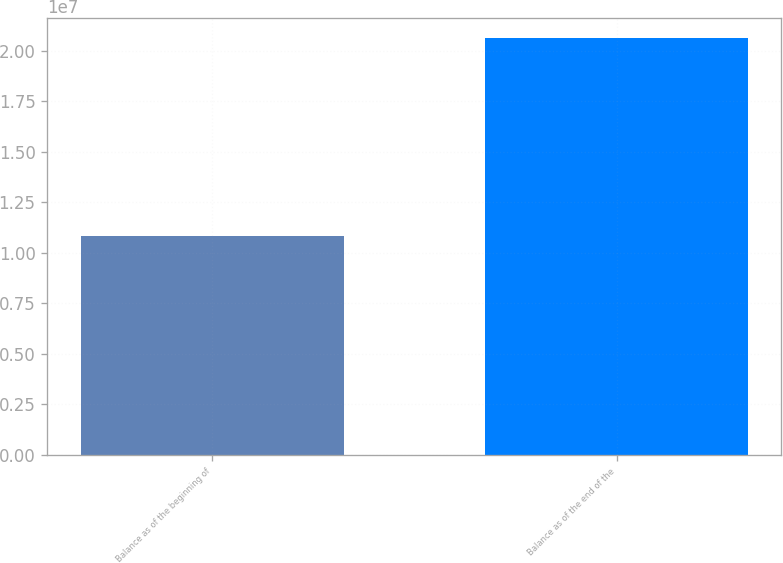<chart> <loc_0><loc_0><loc_500><loc_500><bar_chart><fcel>Balance as of the beginning of<fcel>Balance as of the end of the<nl><fcel>1.08385e+07<fcel>2.06017e+07<nl></chart> 